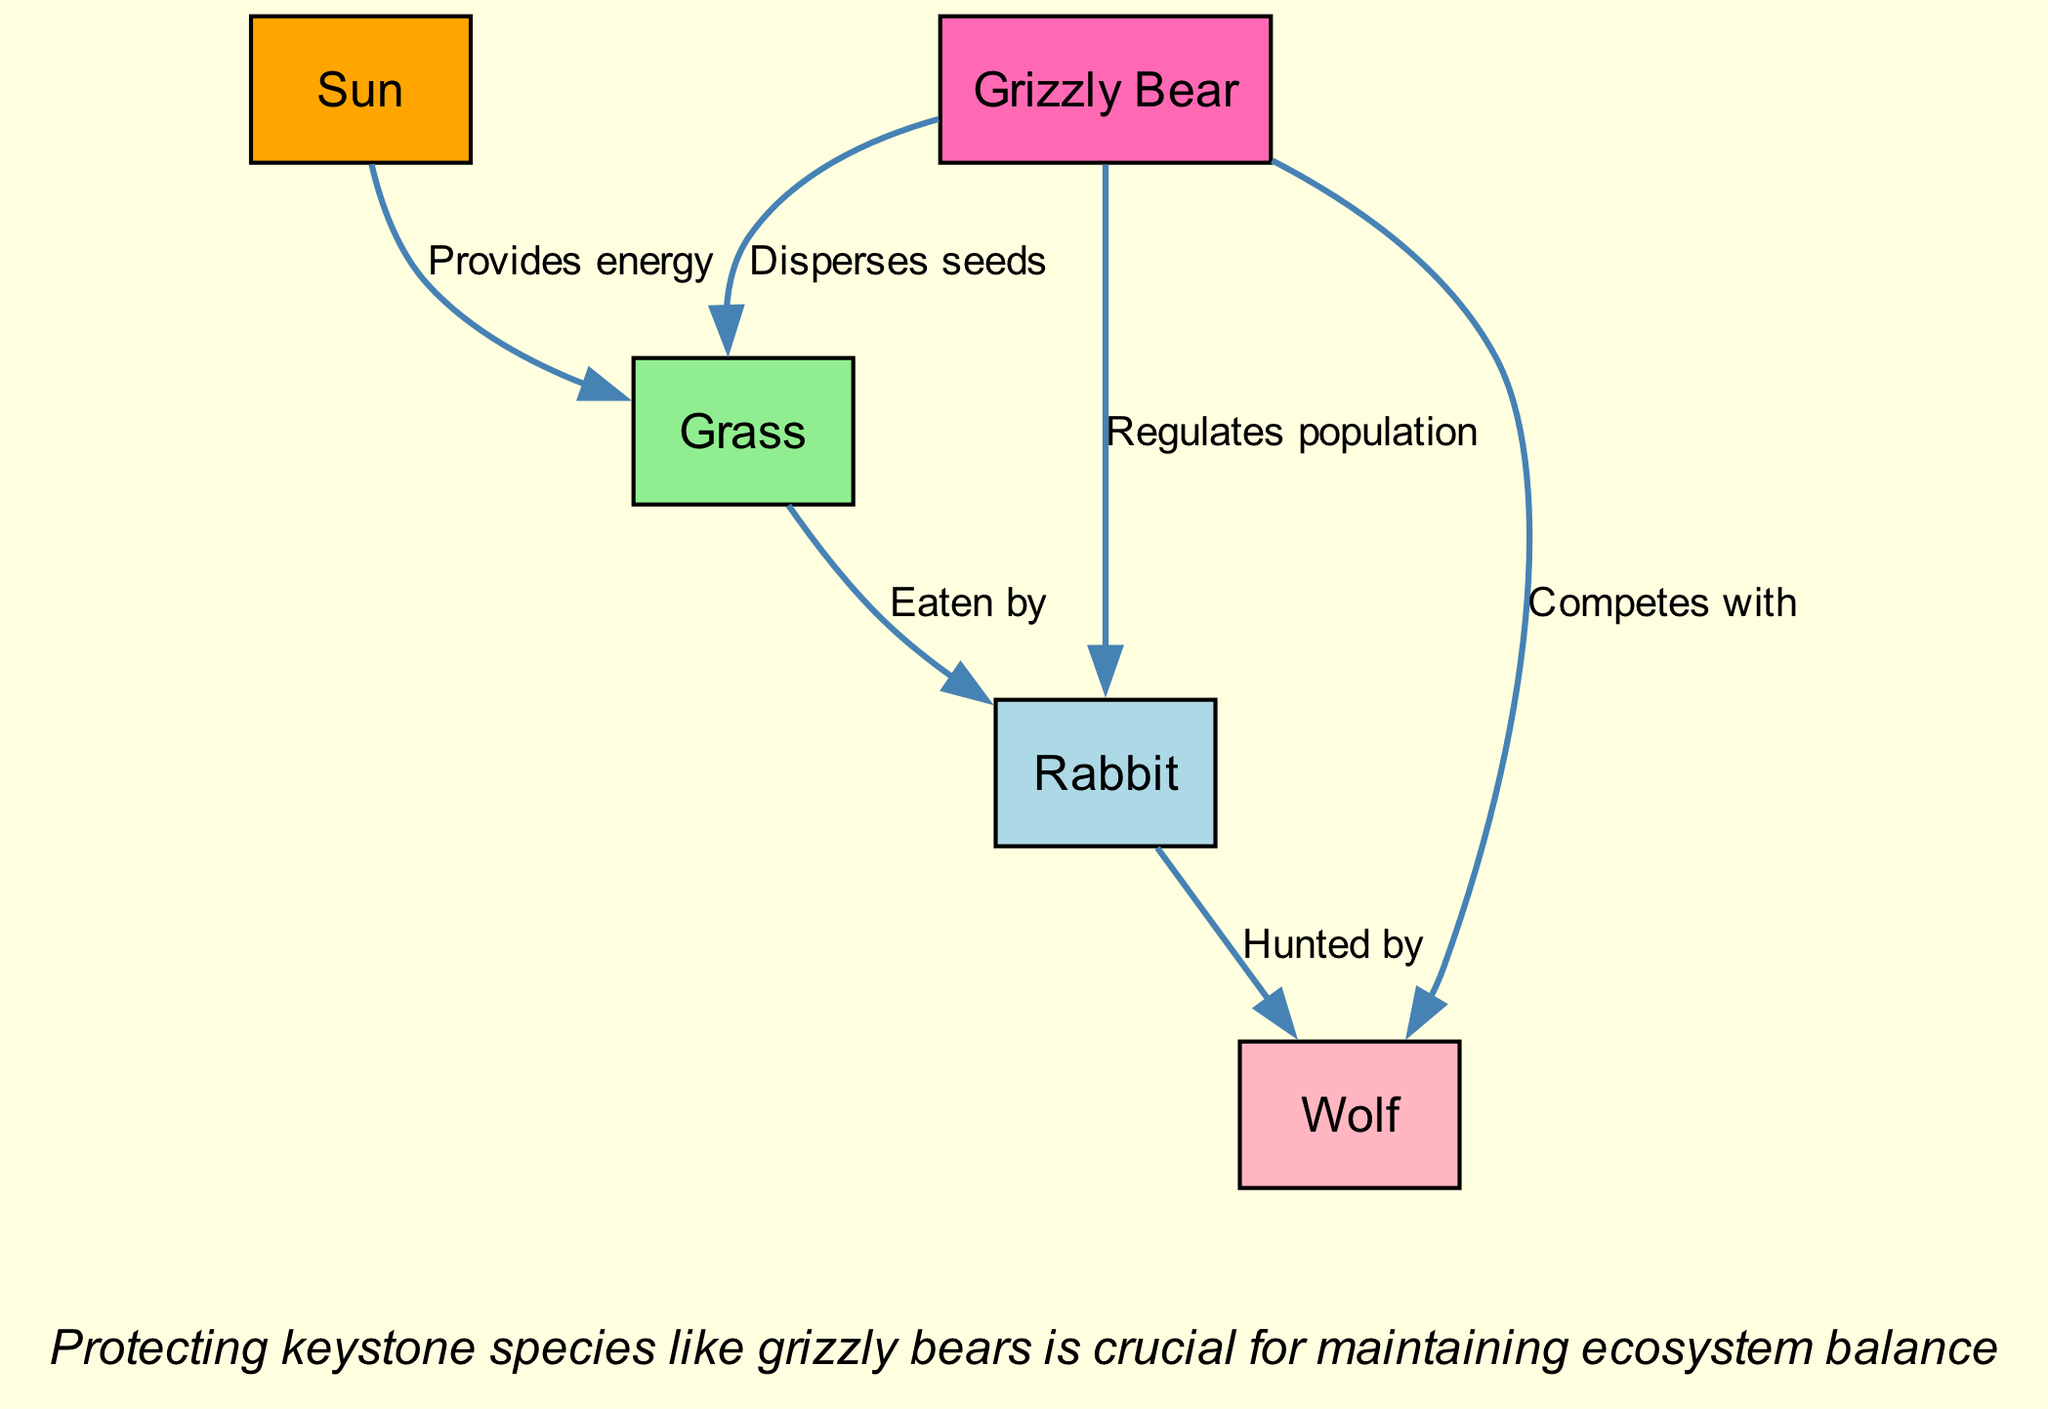What is the source of energy in this food chain? According to the diagram, the first node depicts "Sun" as the main source of energy that initiates the food chain.
Answer: Sun How many nodes are there in the food chain? The diagram shows there are five nodes total: Sun, Grass, Rabbit, Wolf, and Grizzly Bear.
Answer: 5 Which species is considered a keystone species? The diagram highlights "Grizzly Bear" as the only keystone species, indicated by its specific type classification in the nodes.
Answer: Grizzly Bear What does the Grizzly Bear do to the Grass? The diagram indicates that the Grizzly Bear "Disperses seeds," illustrating its role in the ecosystem regarding plant growth.
Answer: Disperses seeds How does the Grizzly Bear interact with the Rabbit? The diagram shows that the Grizzly Bear "Regulates population" of Rabbits, indicating a balance within the food chain through predation and competition.
Answer: Regulates population How many edges are connected to the Wolf? From the diagram, the Wolf has three edges connecting it to other species: one from Rabbit, one from Grizzly Bear, and one from Grass.
Answer: 3 What is the relationship between the Sun and Grass? The edge leading from the Sun to Grass is labeled "Provides energy," signifying that Grass utilizes energy from the Sun for photosynthesis.
Answer: Provides energy Which animal is hunted by the Wolf? The diagram explicitly states that the Wolf "Hunted by" the Rabbit, showing a direct predator-prey relationship.
Answer: Rabbit What action does the Grizzly Bear perform towards Grass? The diagram shows that the Grizzly Bear "Disperses seeds," which is crucial for the reproductive process of the Grass.
Answer: Disperses seeds What kind of consumer is the Rabbit classified as? According to the diagram, the Rabbit is identified specifically as a "Primary Consumer," which feeds on producers like Grass.
Answer: Primary Consumer 